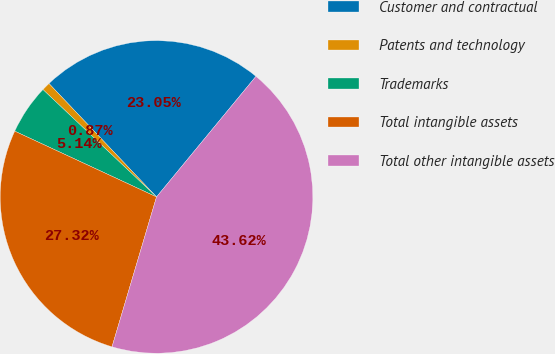Convert chart to OTSL. <chart><loc_0><loc_0><loc_500><loc_500><pie_chart><fcel>Customer and contractual<fcel>Patents and technology<fcel>Trademarks<fcel>Total intangible assets<fcel>Total other intangible assets<nl><fcel>23.05%<fcel>0.87%<fcel>5.14%<fcel>27.32%<fcel>43.62%<nl></chart> 